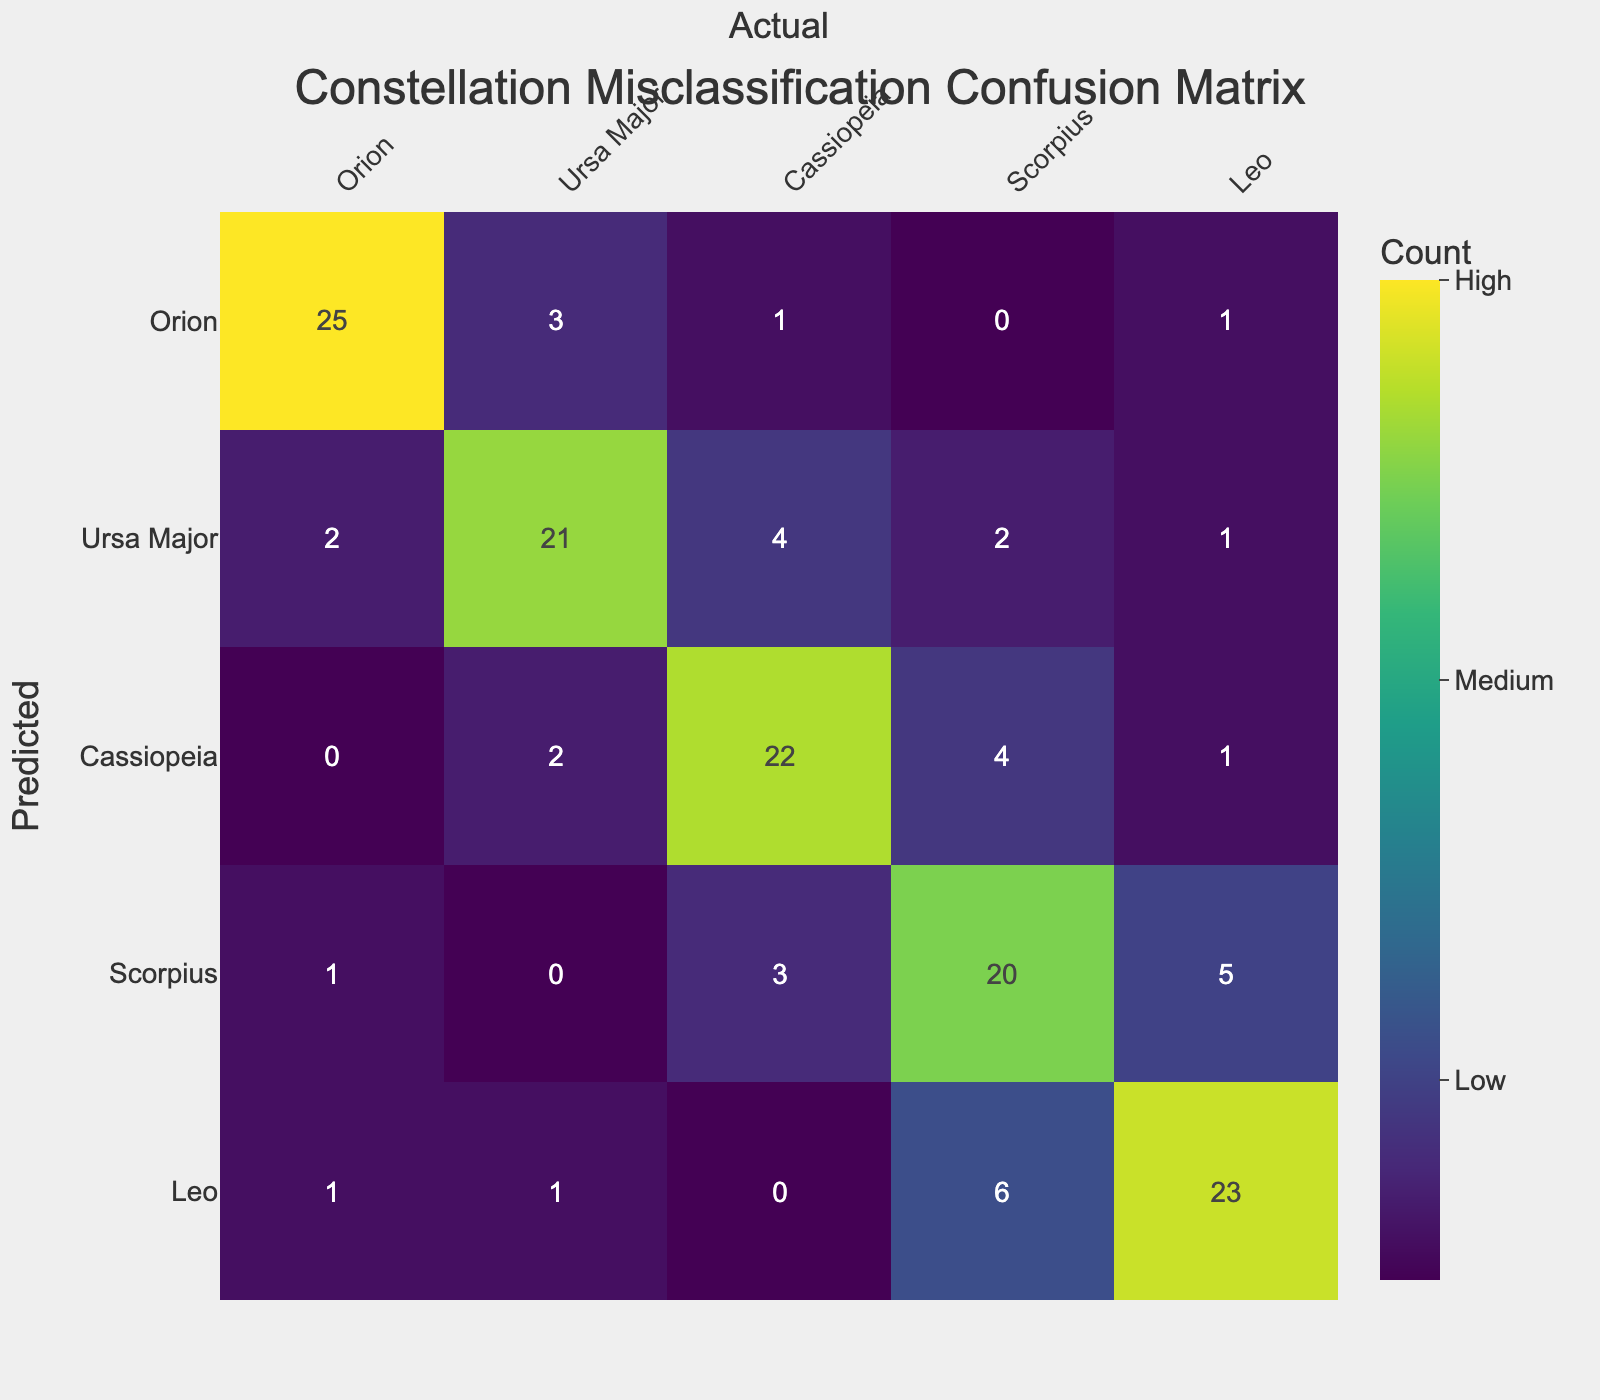What is the number of audience members who predicted Orion correctly? The value in the 'Orion' row and 'Orion' column is 25, indicating that 25 members predicted Orion correctly.
Answer: 25 How many audience members misclassified Cassiopeia as Orion? The value in the 'Cassiopeia' row and 'Orion' column is 0, meaning that none classified Cassiopeia as Orion.
Answer: 0 What is the total number of predictions made for Ursa Major? To find the total predictions for Ursa Major, add the values in the Ursa Major row: 2 (Orion) + 21 (Ursa Major) + 4 (Cassiopeia) + 2 (Scorpius) + 1 (Leo) = 30.
Answer: 30 Is it true that more audience members incorrectly classified Scorpius as Cassiopeia than as Leo? The value for Scorpius misclassified as Cassiopeia is 3, while 5 were misclassified as Leo. Since 3 is less than 5, the statement is false.
Answer: False What percentage of the audience predicted Leo correctly? The predicted counts for Leo is 23 and the total predictions for Leo is 23 + 6 + 0 + 1 + 1 = 31. So, the percentage is (23/31) * 100 ≈ 74.19%.
Answer: 74.19% How many times did the audience confuse Scorpius with other constellations combined? To find this, sum all values in the Scorpius row except the one in the Scorpius column: 1 (Orion) + 0 (Ursa Major) + 3 (Cassiopeia) + 5 (Leo) = 9.
Answer: 9 What is the most frequently misclassified constellation? By looking across all predicted constellations, Ursa Major has the highest misclassification count: 2 (Orion) + 4 (Cassiopeia) + 2 (Scorpius) + 1 (Leo) = 9, more than any other constellation.
Answer: Ursa Major What is the difference in the number of audience members predicting Cassiopeia as Cassiopeia versus as Ursa Major? The value for 'Cassiopeia' as 'Cassiopeia' is 22, and as 'Ursa Major' is 2. The difference is 22 - 2 = 20.
Answer: 20 